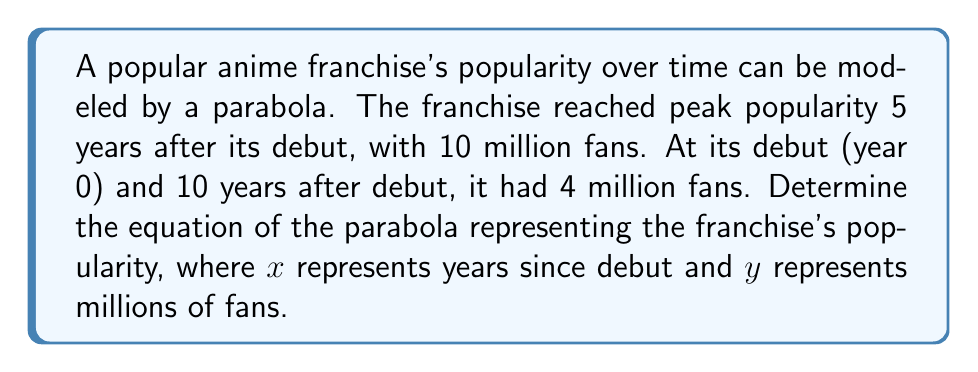Give your solution to this math problem. Let's approach this step-by-step:

1) The general equation of a parabola is $y = a(x-h)^2 + k$, where $(h,k)$ is the vertex.

2) We know the vertex is at (5, 10) because the peak popularity was 10 million fans 5 years after debut. So $h=5$ and $k=10$.

3) Our equation now looks like: $y = a(x-5)^2 + 10$

4) We can use either the debut point (0, 4) or the 10-year point (10, 4) to solve for $a$. Let's use (0, 4):

   $4 = a(0-5)^2 + 10$
   $4 = 25a + 10$
   $-6 = 25a$
   $a = -\frac{6}{25} = -0.24$

5) Therefore, our final equation is:

   $y = -0.24(x-5)^2 + 10$

6) We can verify this with the 10-year point:

   $y = -0.24(10-5)^2 + 10 = -0.24(25) + 10 = -6 + 10 = 4$

   This confirms our equation is correct.
Answer: $y = -0.24(x-5)^2 + 10$ 